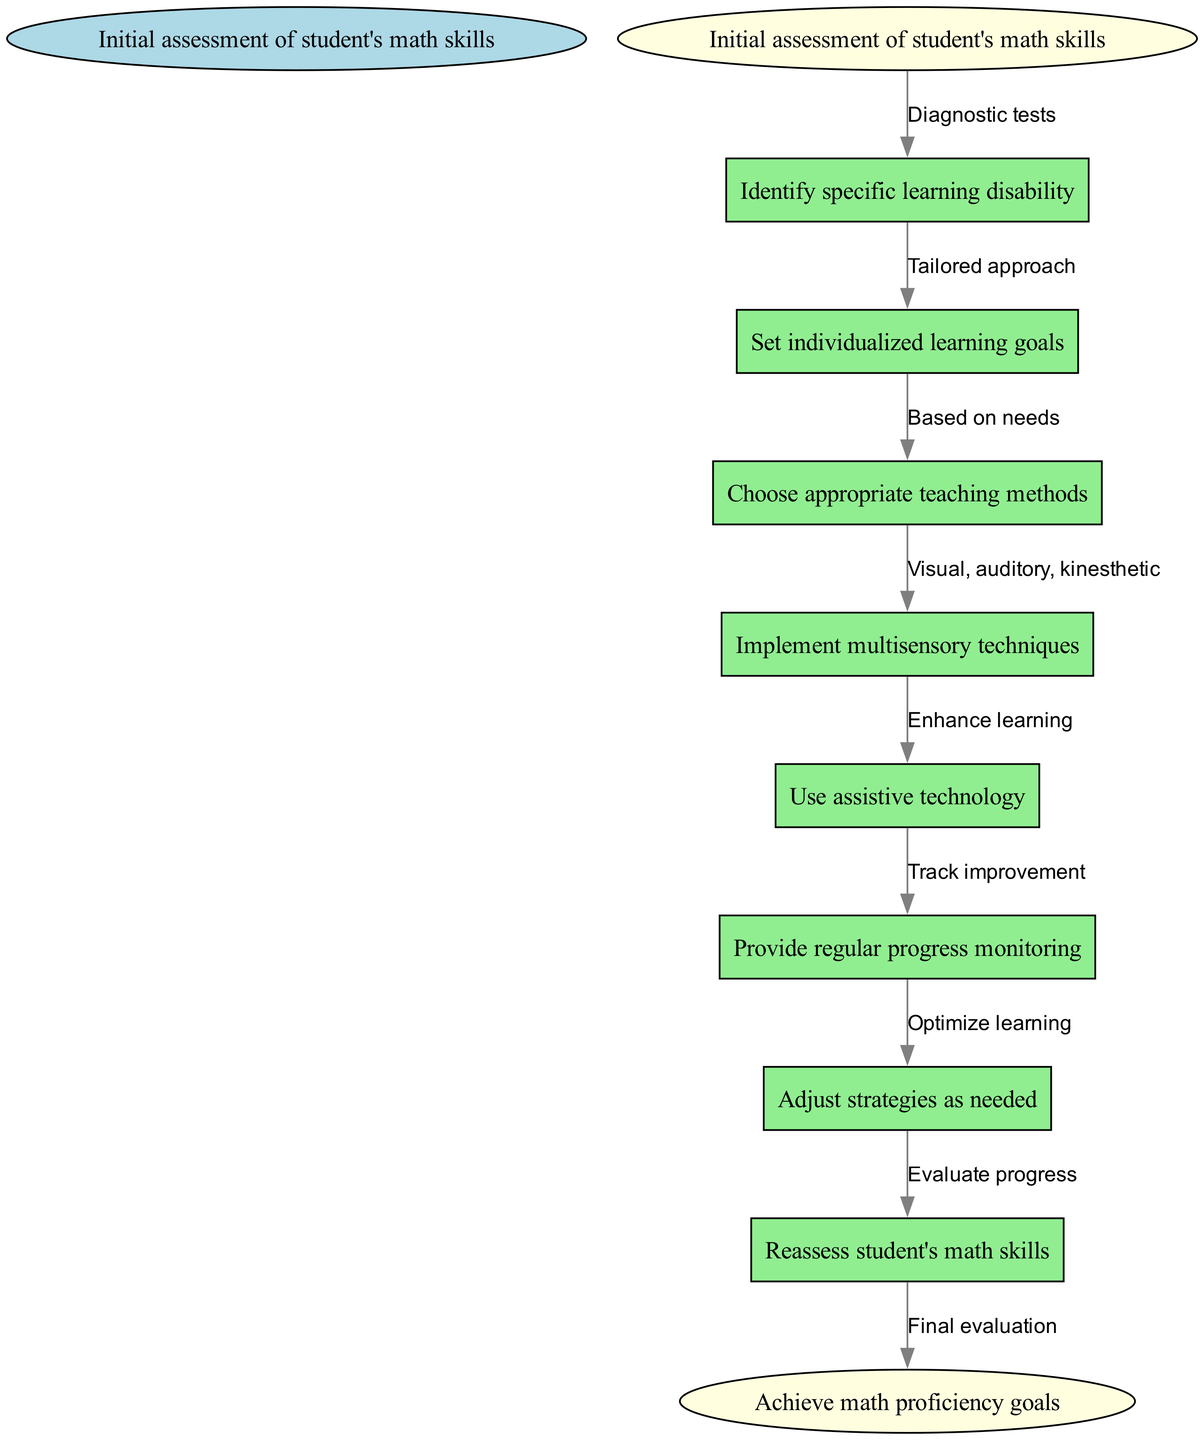What is the starting point of the clinical pathway? The starting point is indicated in the diagram as "Initial assessment of student's math skills". This is explicitly listed at the top of the hierarchy, marking the beginning of the process.
Answer: Initial assessment of student's math skills How many nodes are in the diagram? The total number of nodes includes the start, the individual steps (learning goals, methods, etc.), and the end node. Counting all of these gives a total of 8 nodes.
Answer: 8 What is the final step in the pathway labeled as? The end of the clinical pathway is labeled as "Achieve math proficiency goals," which indicates the desired outcome after following all previous steps. This is explicitly stated in the diagram.
Answer: Achieve math proficiency goals Which node follows "Choose appropriate teaching methods"? Following "Choose appropriate teaching methods" is "Implement multisensory techniques". This link shows the flow from selecting methods to putting them into practice.
Answer: Implement multisensory techniques What type of approach is emphasized after identifying the specific learning disability? The diagram emphasizes a "Tailored approach," which denotes customized strategies that reflect the unique needs of the student identified earlier in the process.
Answer: Tailored approach How is progress monitored in this pathway? Progress is monitored through "Provide regular progress monitoring." This step highlights the importance of ongoing assessment to evaluate the student's development throughout the learning process.
Answer: Provide regular progress monitoring What label describes the connection between "Implement multisensory techniques" and "Use assistive technology"? The connection is described by the label "Enhance learning". This indicates that the use of assistive technology is intended to support the techniques already implemented, aiming to improve the learning experience.
Answer: Enhance learning After adjusting strategies, what is the next step? The next step after adjusting strategies is "Reassess student's math skills." This indicates the need for evaluation to determine the effectiveness of the adjustments made in the teaching approach.
Answer: Reassess student's math skills What happens right after setting individualized learning goals? After setting individualized learning goals, the subsequent step is "Choose appropriate teaching methods". This indicates that establishing goals leads directly to selecting how to teach effectively based on those goals.
Answer: Choose appropriate teaching methods 